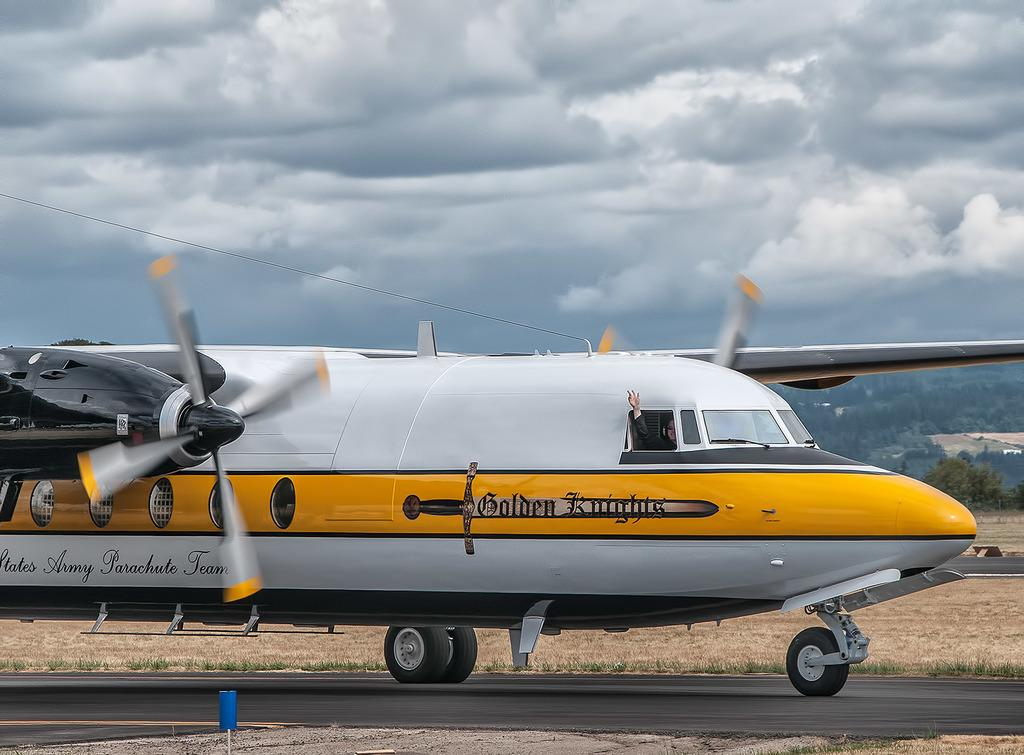What is the person in the image doing? There is a person sitting inside the airplane. What can be seen in the background of the image? There are buildings, trees, and the sky visible in the background of the image. What type of loaf is the person holding in the image? There is no loaf present in the image; the person is sitting inside an airplane. 